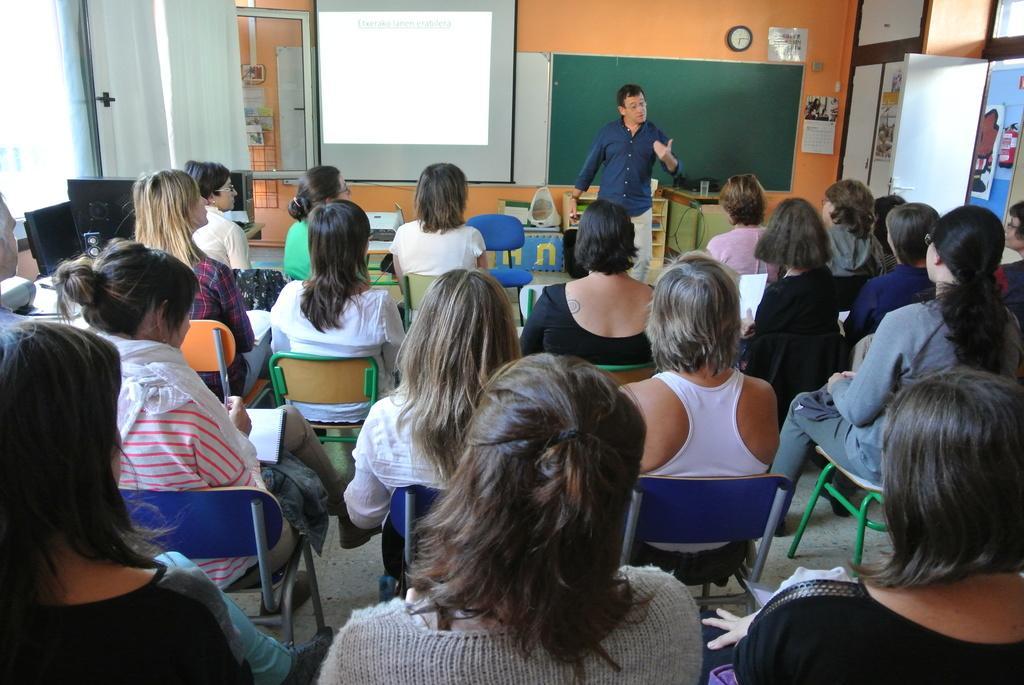How would you summarize this image in a sentence or two? In this image we can see people sitting on the chairs, boards, curtains, clock, posters, door and we can also see a person standing. 